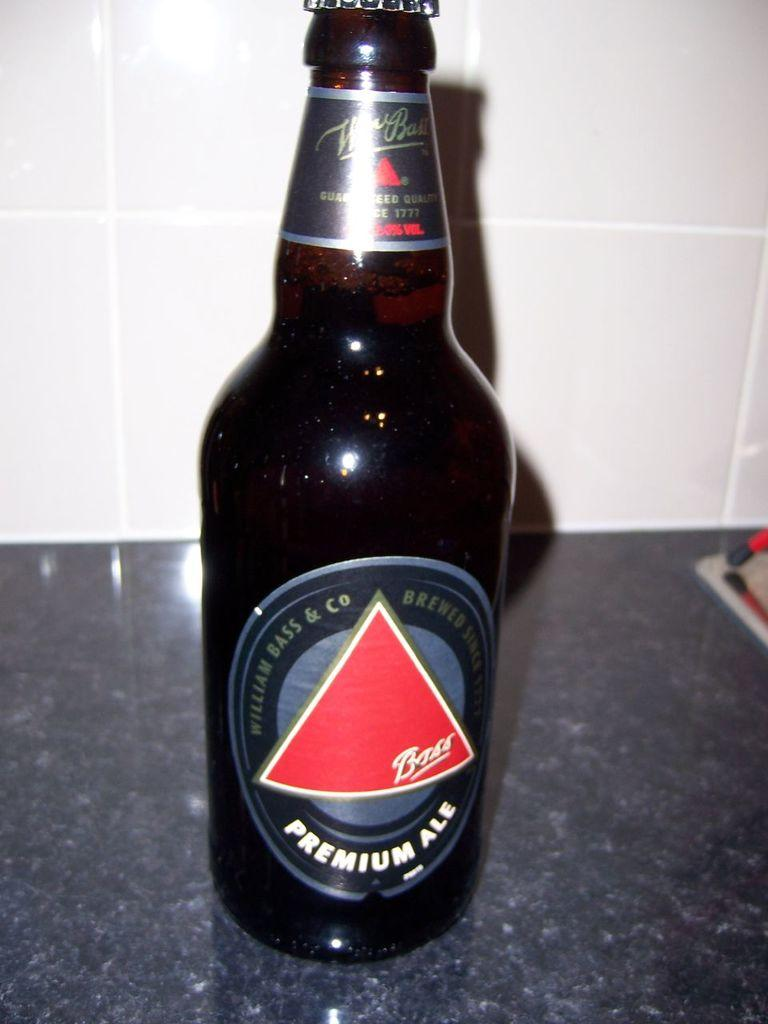<image>
Offer a succinct explanation of the picture presented. A bottle with a red triangle on the label contains premium ale. 